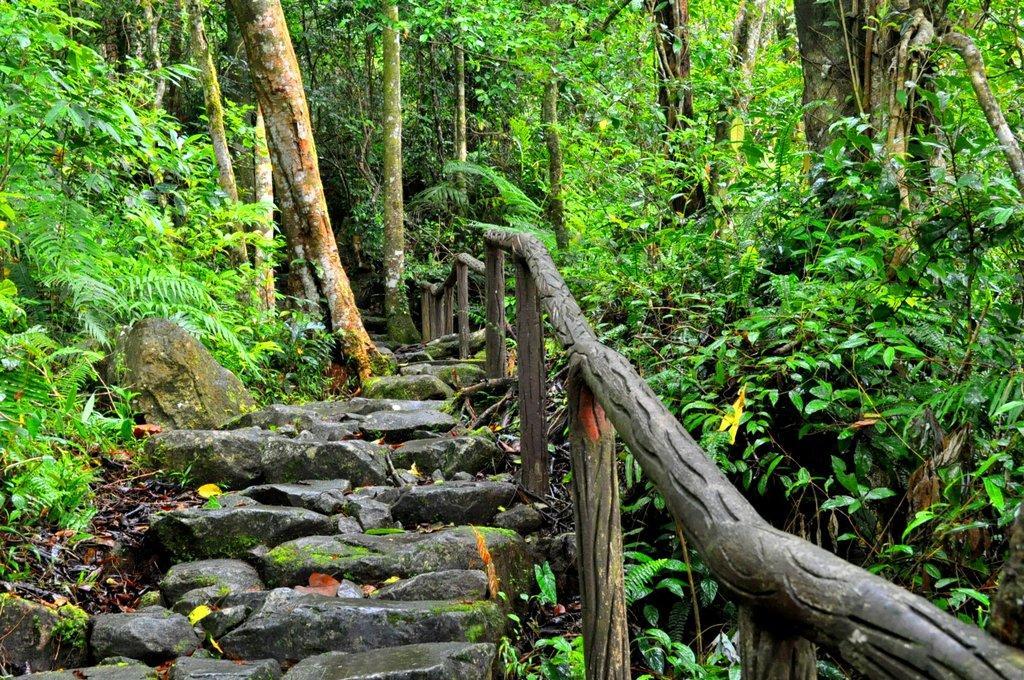Please provide a concise description of this image. We can see stones,wooden fence,plants and trees. 